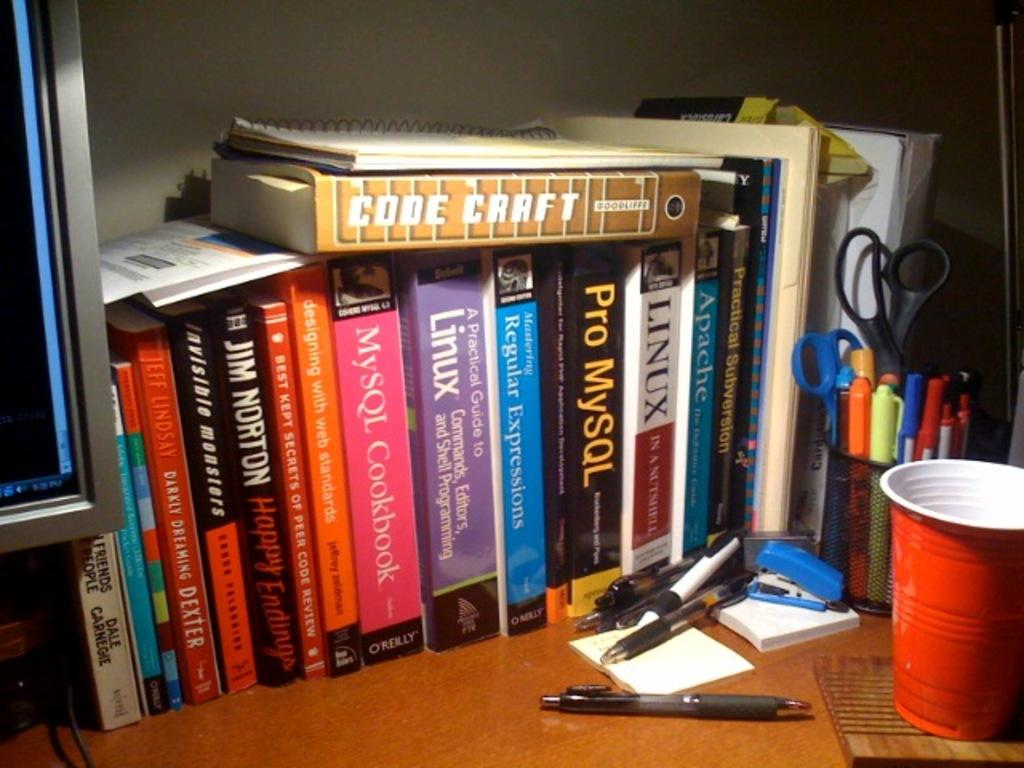<image>
Summarize the visual content of the image. Several books are arranged side to side with a copy of codecraft sitting on top of the pile. 